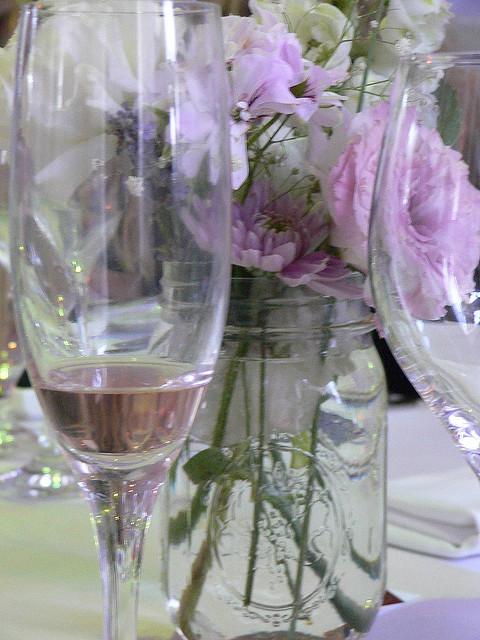What color is the flower?
Short answer required. Purple. How many drinking glasses are visible?
Give a very brief answer. 2. Is there a mason jar for a vase?
Be succinct. Yes. 